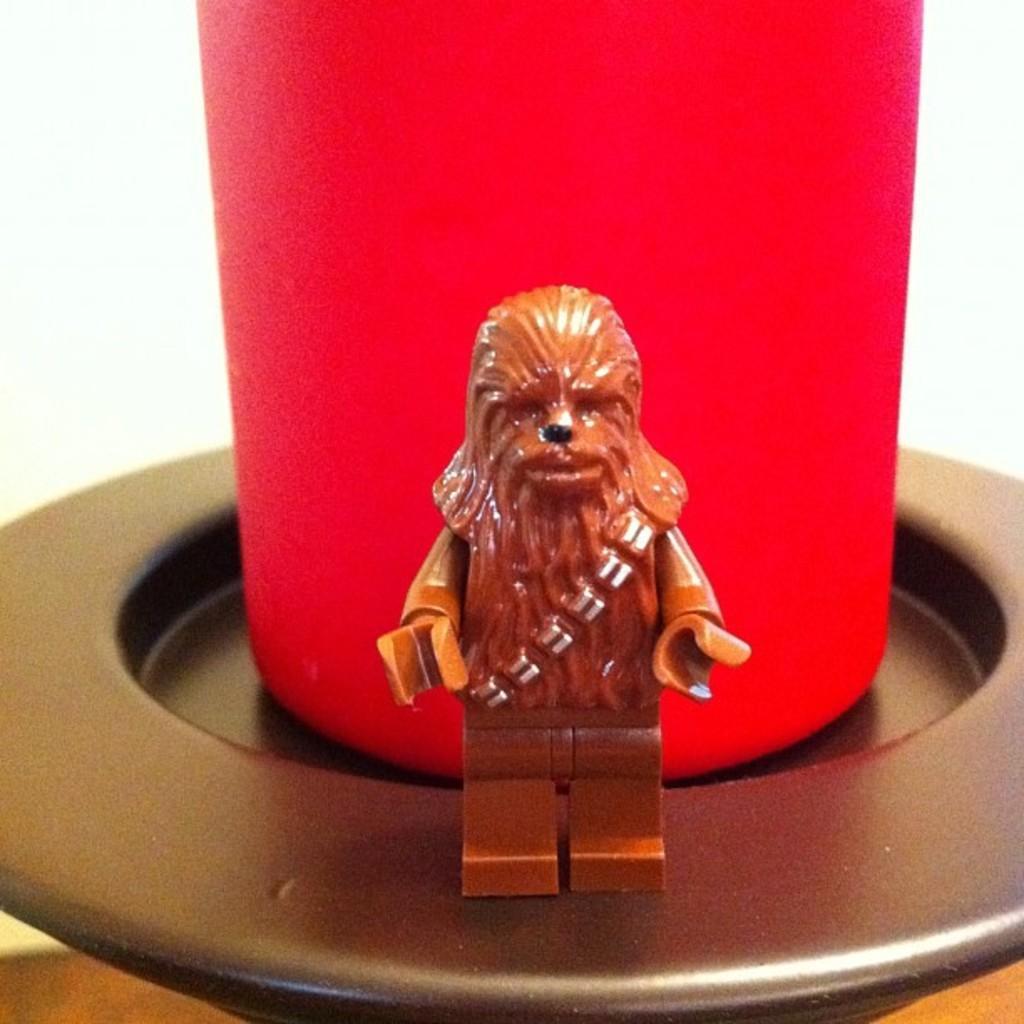Describe this image in one or two sentences. In this image I can see a small sculpture at the front. There is a red glass on a black surface. There is a white surface. 